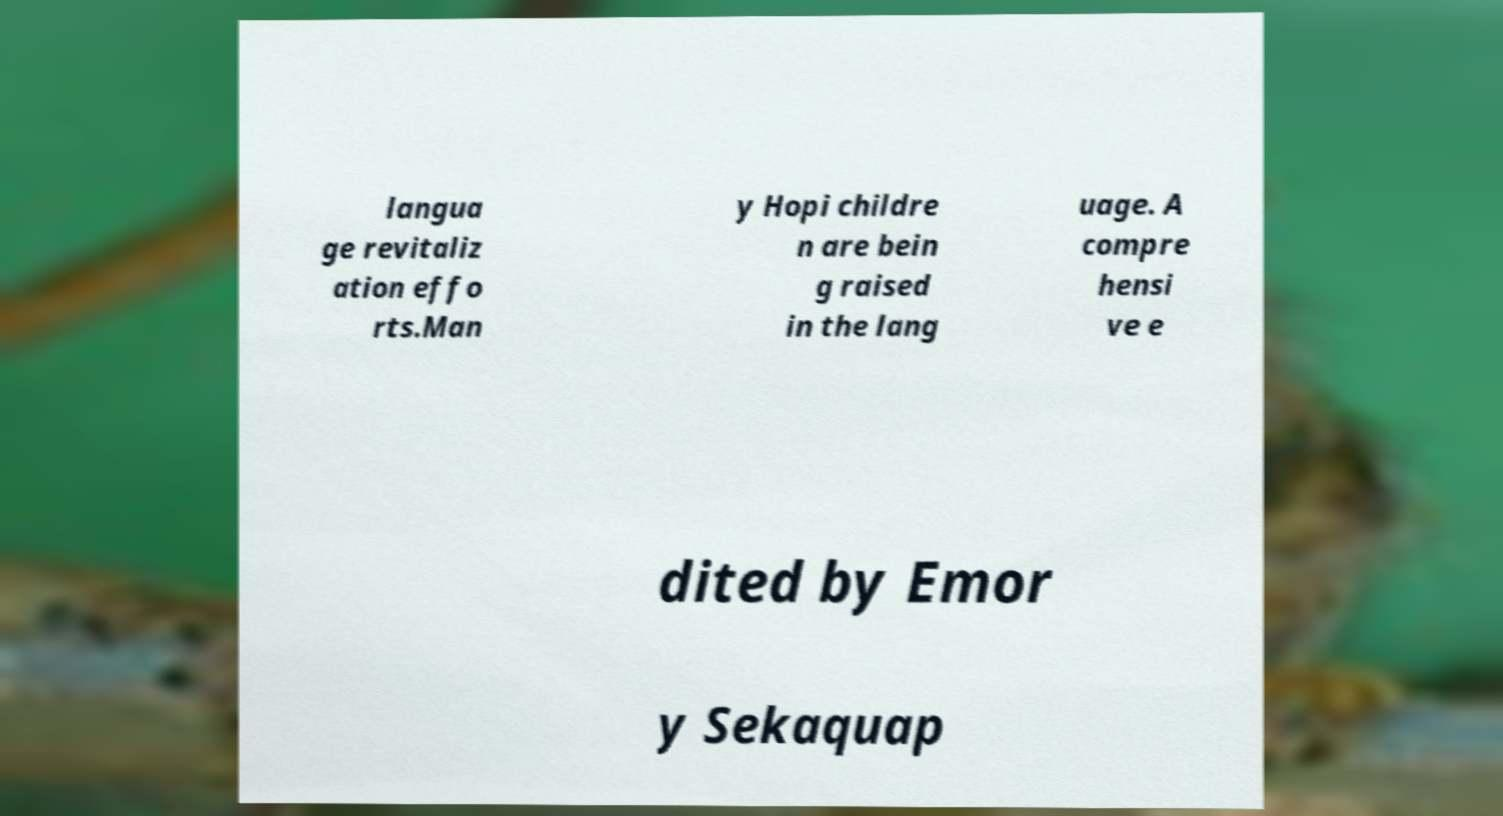There's text embedded in this image that I need extracted. Can you transcribe it verbatim? langua ge revitaliz ation effo rts.Man y Hopi childre n are bein g raised in the lang uage. A compre hensi ve e dited by Emor y Sekaquap 